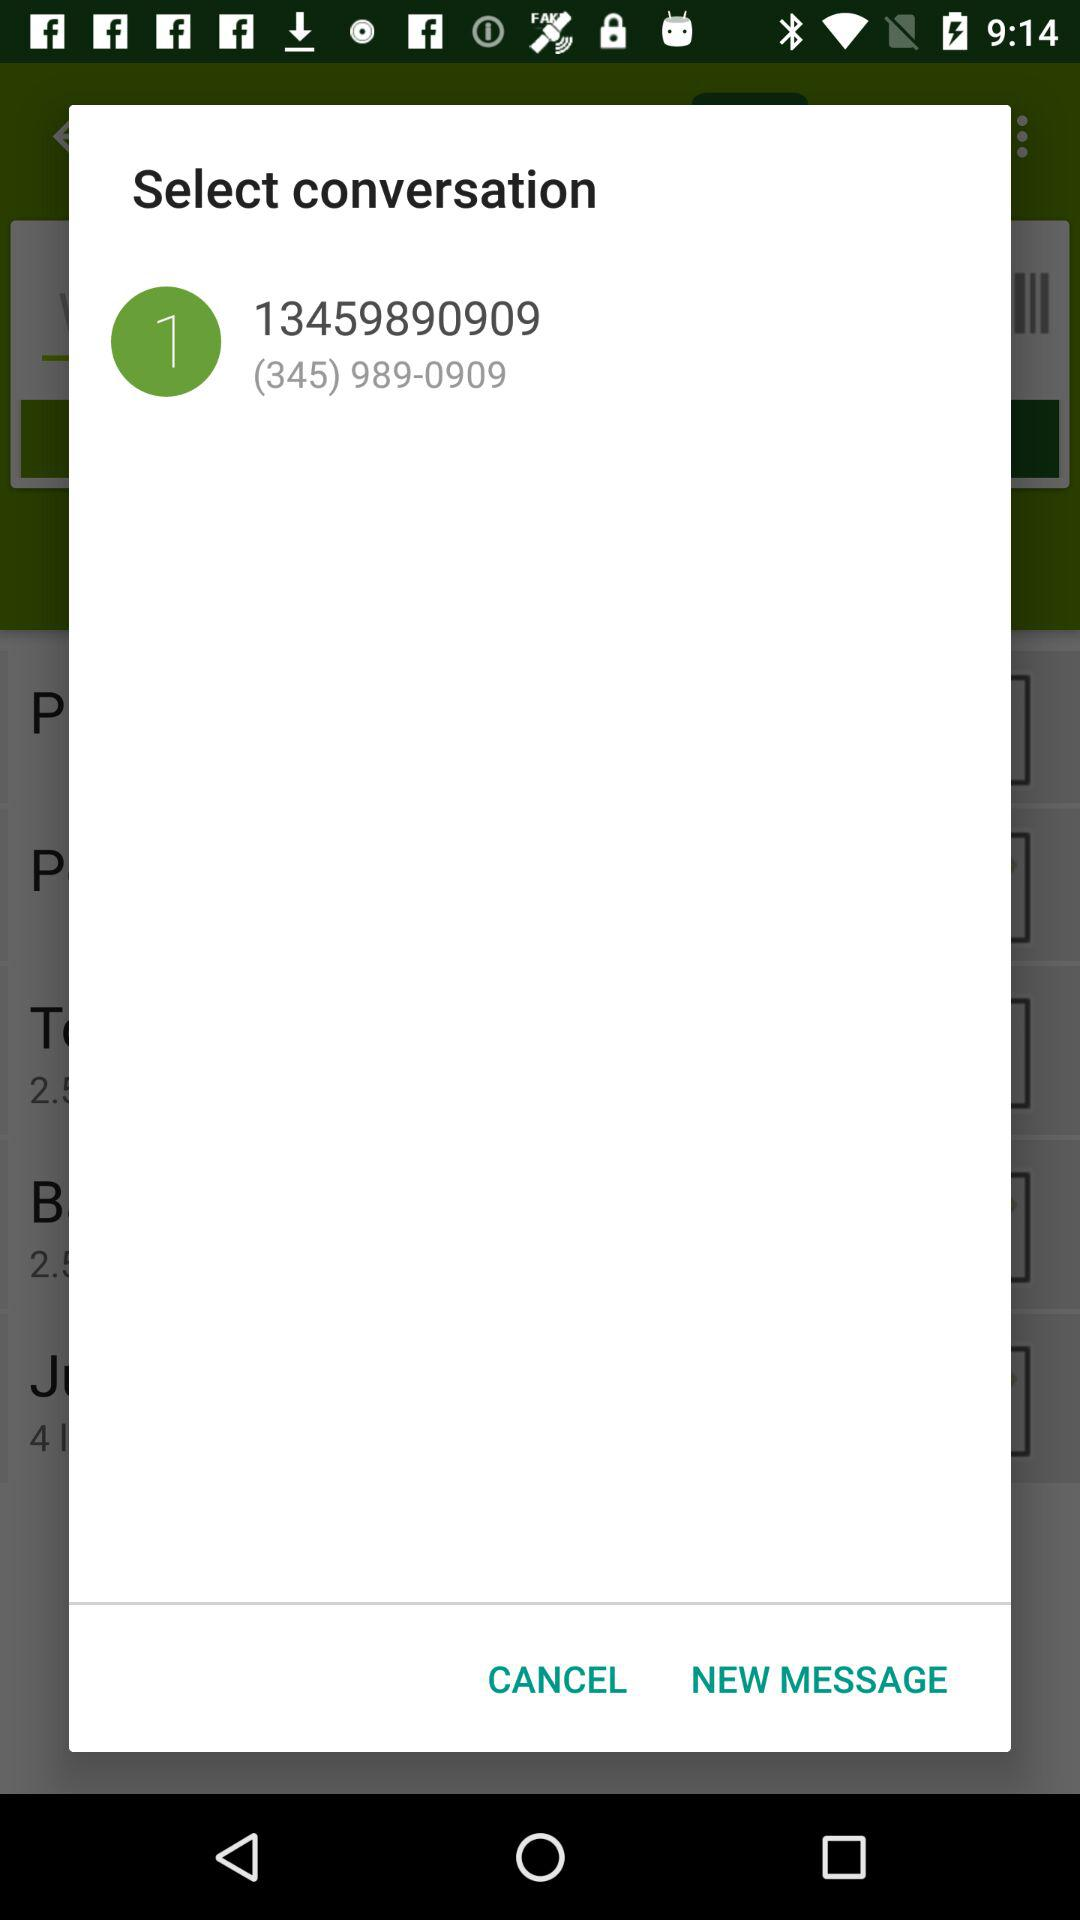How many digits are in the phone number?
Answer the question using a single word or phrase. 10 